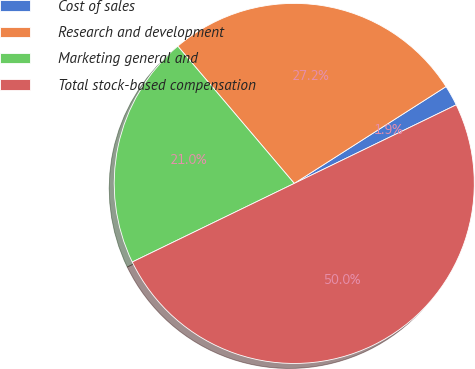Convert chart. <chart><loc_0><loc_0><loc_500><loc_500><pie_chart><fcel>Cost of sales<fcel>Research and development<fcel>Marketing general and<fcel>Total stock-based compensation<nl><fcel>1.85%<fcel>27.16%<fcel>20.99%<fcel>50.0%<nl></chart> 